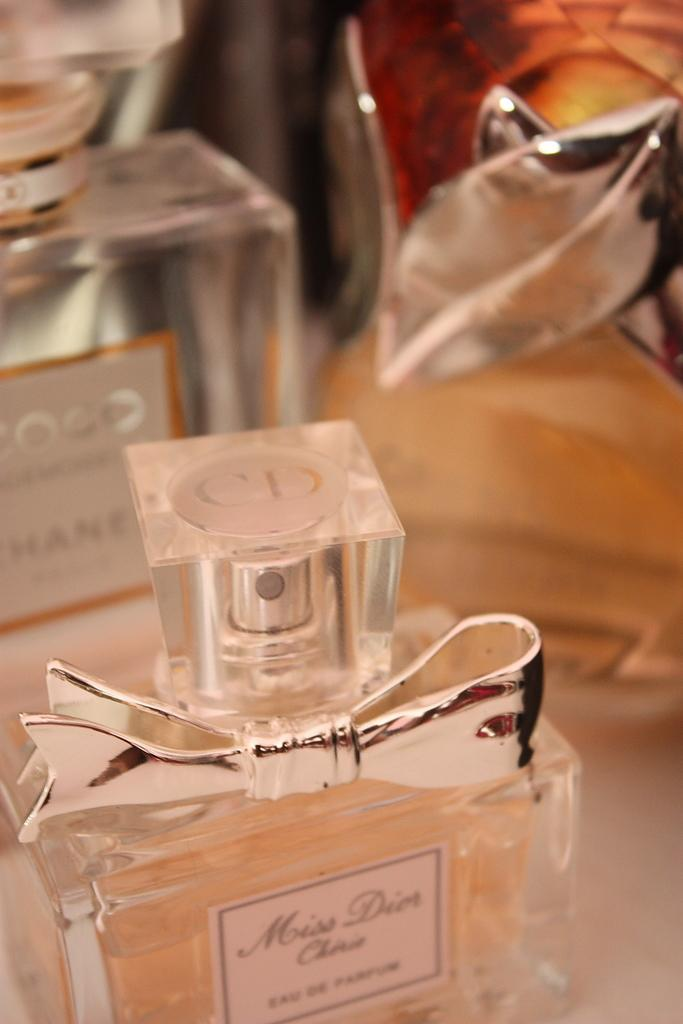<image>
Describe the image concisely. the word miss can be seen on the clear bottle 